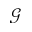Convert formula to latex. <formula><loc_0><loc_0><loc_500><loc_500>\mathcal { G }</formula> 